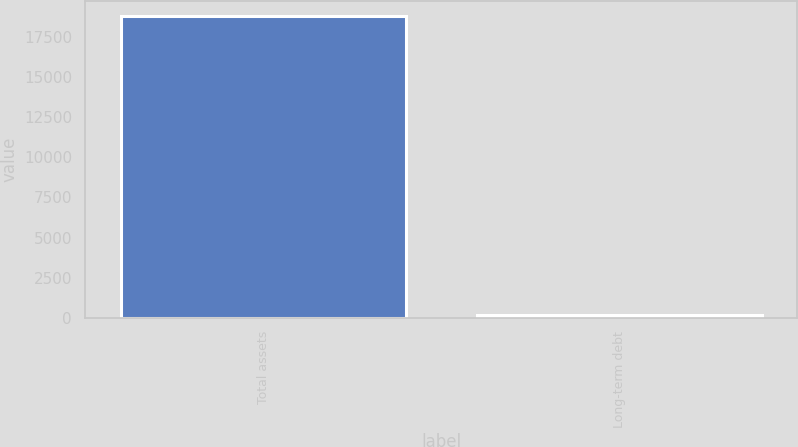Convert chart. <chart><loc_0><loc_0><loc_500><loc_500><bar_chart><fcel>Total assets<fcel>Long-term debt<nl><fcel>18797<fcel>184<nl></chart> 